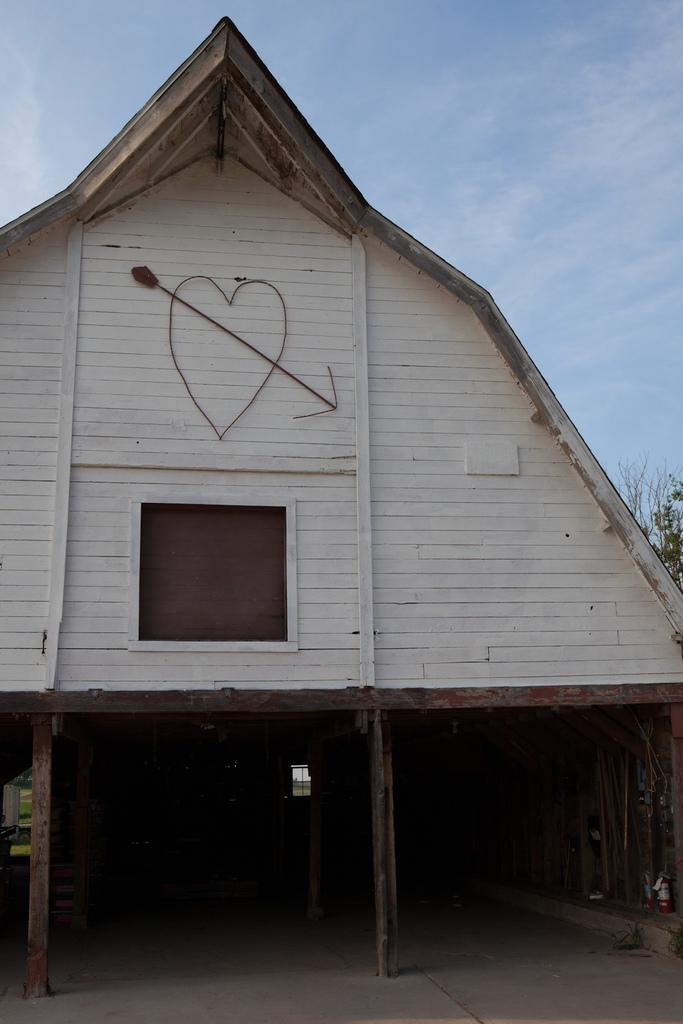What type of house is in the picture? There is a wooden house in the picture. What other natural element is present in the picture? There is a tree in the picture. How would you describe the sky in the picture? The sky is blue and cloudy in the picture. Where is the desk located in the picture? There is no desk present in the picture. What type of trousers are hanging on the tree in the picture? There are no trousers present in the picture. 